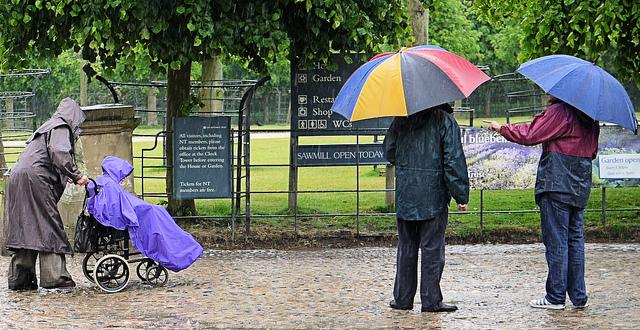What is the purple outfit the woman is wearing called?

Choices:
A) smock
B) blanket
C) poncho
D) robe poncho 